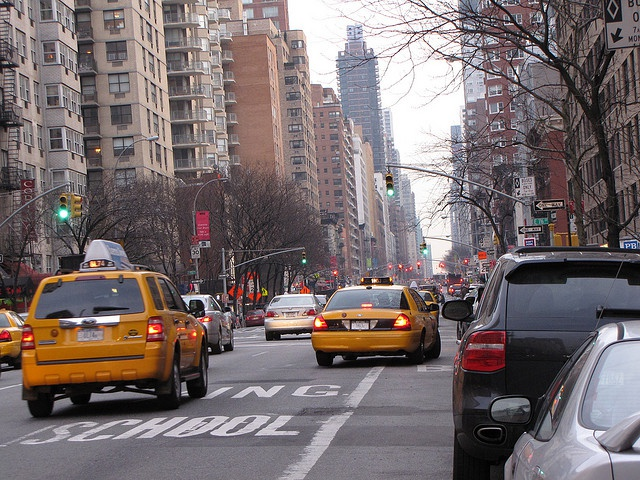Describe the objects in this image and their specific colors. I can see car in tan, black, gray, and maroon tones, car in tan, red, black, gray, and maroon tones, car in tan, darkgray, lavender, and gray tones, car in tan, black, brown, maroon, and darkgray tones, and car in tan, lightgray, black, darkgray, and gray tones in this image. 